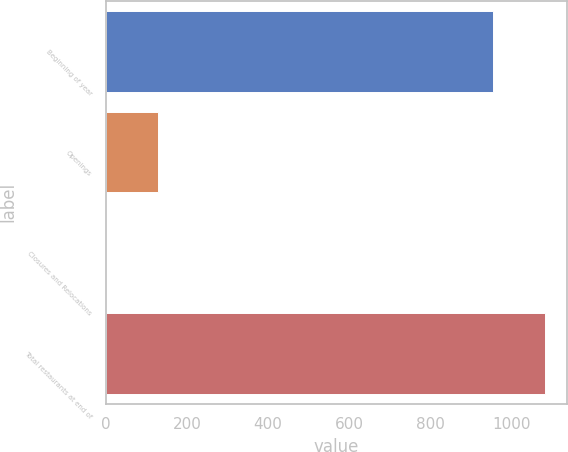<chart> <loc_0><loc_0><loc_500><loc_500><bar_chart><fcel>Beginning of year<fcel>Openings<fcel>Closures and Relocations<fcel>Total restaurants at end of<nl><fcel>956<fcel>129<fcel>1<fcel>1084<nl></chart> 